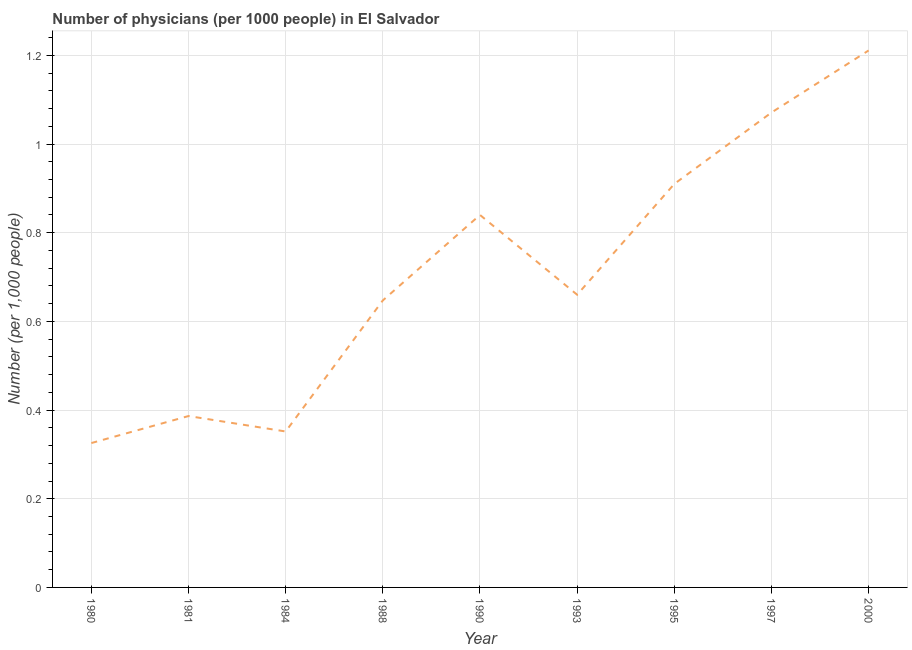What is the number of physicians in 2000?
Give a very brief answer. 1.21. Across all years, what is the maximum number of physicians?
Ensure brevity in your answer.  1.21. Across all years, what is the minimum number of physicians?
Your answer should be very brief. 0.33. In which year was the number of physicians maximum?
Ensure brevity in your answer.  2000. What is the sum of the number of physicians?
Offer a terse response. 6.4. What is the difference between the number of physicians in 1984 and 1997?
Your response must be concise. -0.72. What is the average number of physicians per year?
Offer a terse response. 0.71. What is the median number of physicians?
Your response must be concise. 0.66. What is the ratio of the number of physicians in 1984 to that in 1995?
Ensure brevity in your answer.  0.39. What is the difference between the highest and the second highest number of physicians?
Provide a short and direct response. 0.14. What is the difference between the highest and the lowest number of physicians?
Your answer should be very brief. 0.89. Does the number of physicians monotonically increase over the years?
Provide a succinct answer. No. How many lines are there?
Offer a terse response. 1. How many years are there in the graph?
Ensure brevity in your answer.  9. What is the difference between two consecutive major ticks on the Y-axis?
Your response must be concise. 0.2. Does the graph contain any zero values?
Offer a terse response. No. What is the title of the graph?
Offer a terse response. Number of physicians (per 1000 people) in El Salvador. What is the label or title of the X-axis?
Offer a terse response. Year. What is the label or title of the Y-axis?
Provide a short and direct response. Number (per 1,0 people). What is the Number (per 1,000 people) in 1980?
Your answer should be compact. 0.33. What is the Number (per 1,000 people) of 1981?
Make the answer very short. 0.39. What is the Number (per 1,000 people) in 1984?
Make the answer very short. 0.35. What is the Number (per 1,000 people) in 1988?
Give a very brief answer. 0.65. What is the Number (per 1,000 people) in 1990?
Your answer should be compact. 0.84. What is the Number (per 1,000 people) of 1993?
Your answer should be compact. 0.66. What is the Number (per 1,000 people) in 1995?
Give a very brief answer. 0.91. What is the Number (per 1,000 people) of 1997?
Keep it short and to the point. 1.07. What is the Number (per 1,000 people) of 2000?
Provide a succinct answer. 1.21. What is the difference between the Number (per 1,000 people) in 1980 and 1981?
Make the answer very short. -0.06. What is the difference between the Number (per 1,000 people) in 1980 and 1984?
Your answer should be very brief. -0.03. What is the difference between the Number (per 1,000 people) in 1980 and 1988?
Keep it short and to the point. -0.32. What is the difference between the Number (per 1,000 people) in 1980 and 1990?
Make the answer very short. -0.51. What is the difference between the Number (per 1,000 people) in 1980 and 1993?
Give a very brief answer. -0.33. What is the difference between the Number (per 1,000 people) in 1980 and 1995?
Your answer should be very brief. -0.58. What is the difference between the Number (per 1,000 people) in 1980 and 1997?
Your answer should be compact. -0.75. What is the difference between the Number (per 1,000 people) in 1980 and 2000?
Provide a short and direct response. -0.89. What is the difference between the Number (per 1,000 people) in 1981 and 1984?
Your answer should be very brief. 0.03. What is the difference between the Number (per 1,000 people) in 1981 and 1988?
Your answer should be very brief. -0.26. What is the difference between the Number (per 1,000 people) in 1981 and 1990?
Make the answer very short. -0.45. What is the difference between the Number (per 1,000 people) in 1981 and 1993?
Your answer should be very brief. -0.27. What is the difference between the Number (per 1,000 people) in 1981 and 1995?
Provide a succinct answer. -0.52. What is the difference between the Number (per 1,000 people) in 1981 and 1997?
Ensure brevity in your answer.  -0.68. What is the difference between the Number (per 1,000 people) in 1981 and 2000?
Your answer should be very brief. -0.82. What is the difference between the Number (per 1,000 people) in 1984 and 1988?
Your response must be concise. -0.3. What is the difference between the Number (per 1,000 people) in 1984 and 1990?
Your response must be concise. -0.49. What is the difference between the Number (per 1,000 people) in 1984 and 1993?
Your answer should be compact. -0.31. What is the difference between the Number (per 1,000 people) in 1984 and 1995?
Offer a very short reply. -0.56. What is the difference between the Number (per 1,000 people) in 1984 and 1997?
Make the answer very short. -0.72. What is the difference between the Number (per 1,000 people) in 1984 and 2000?
Provide a short and direct response. -0.86. What is the difference between the Number (per 1,000 people) in 1988 and 1990?
Offer a very short reply. -0.19. What is the difference between the Number (per 1,000 people) in 1988 and 1993?
Your answer should be compact. -0.01. What is the difference between the Number (per 1,000 people) in 1988 and 1995?
Provide a short and direct response. -0.26. What is the difference between the Number (per 1,000 people) in 1988 and 1997?
Ensure brevity in your answer.  -0.42. What is the difference between the Number (per 1,000 people) in 1988 and 2000?
Keep it short and to the point. -0.56. What is the difference between the Number (per 1,000 people) in 1990 and 1993?
Keep it short and to the point. 0.18. What is the difference between the Number (per 1,000 people) in 1990 and 1995?
Your response must be concise. -0.07. What is the difference between the Number (per 1,000 people) in 1990 and 1997?
Your response must be concise. -0.23. What is the difference between the Number (per 1,000 people) in 1990 and 2000?
Give a very brief answer. -0.37. What is the difference between the Number (per 1,000 people) in 1993 and 1995?
Ensure brevity in your answer.  -0.25. What is the difference between the Number (per 1,000 people) in 1993 and 1997?
Offer a terse response. -0.41. What is the difference between the Number (per 1,000 people) in 1993 and 2000?
Give a very brief answer. -0.55. What is the difference between the Number (per 1,000 people) in 1995 and 1997?
Make the answer very short. -0.16. What is the difference between the Number (per 1,000 people) in 1995 and 2000?
Give a very brief answer. -0.3. What is the difference between the Number (per 1,000 people) in 1997 and 2000?
Keep it short and to the point. -0.14. What is the ratio of the Number (per 1,000 people) in 1980 to that in 1981?
Provide a succinct answer. 0.84. What is the ratio of the Number (per 1,000 people) in 1980 to that in 1984?
Provide a short and direct response. 0.93. What is the ratio of the Number (per 1,000 people) in 1980 to that in 1988?
Provide a short and direct response. 0.5. What is the ratio of the Number (per 1,000 people) in 1980 to that in 1990?
Your response must be concise. 0.39. What is the ratio of the Number (per 1,000 people) in 1980 to that in 1993?
Offer a very short reply. 0.49. What is the ratio of the Number (per 1,000 people) in 1980 to that in 1995?
Offer a very short reply. 0.36. What is the ratio of the Number (per 1,000 people) in 1980 to that in 1997?
Your answer should be very brief. 0.3. What is the ratio of the Number (per 1,000 people) in 1980 to that in 2000?
Your response must be concise. 0.27. What is the ratio of the Number (per 1,000 people) in 1981 to that in 1984?
Offer a very short reply. 1.1. What is the ratio of the Number (per 1,000 people) in 1981 to that in 1988?
Ensure brevity in your answer.  0.6. What is the ratio of the Number (per 1,000 people) in 1981 to that in 1990?
Your response must be concise. 0.46. What is the ratio of the Number (per 1,000 people) in 1981 to that in 1993?
Ensure brevity in your answer.  0.59. What is the ratio of the Number (per 1,000 people) in 1981 to that in 1995?
Keep it short and to the point. 0.42. What is the ratio of the Number (per 1,000 people) in 1981 to that in 1997?
Keep it short and to the point. 0.36. What is the ratio of the Number (per 1,000 people) in 1981 to that in 2000?
Ensure brevity in your answer.  0.32. What is the ratio of the Number (per 1,000 people) in 1984 to that in 1988?
Give a very brief answer. 0.54. What is the ratio of the Number (per 1,000 people) in 1984 to that in 1990?
Keep it short and to the point. 0.42. What is the ratio of the Number (per 1,000 people) in 1984 to that in 1993?
Provide a succinct answer. 0.53. What is the ratio of the Number (per 1,000 people) in 1984 to that in 1995?
Offer a terse response. 0.39. What is the ratio of the Number (per 1,000 people) in 1984 to that in 1997?
Your response must be concise. 0.33. What is the ratio of the Number (per 1,000 people) in 1984 to that in 2000?
Your answer should be compact. 0.29. What is the ratio of the Number (per 1,000 people) in 1988 to that in 1990?
Keep it short and to the point. 0.77. What is the ratio of the Number (per 1,000 people) in 1988 to that in 1993?
Give a very brief answer. 0.98. What is the ratio of the Number (per 1,000 people) in 1988 to that in 1995?
Your answer should be compact. 0.71. What is the ratio of the Number (per 1,000 people) in 1988 to that in 1997?
Keep it short and to the point. 0.6. What is the ratio of the Number (per 1,000 people) in 1988 to that in 2000?
Your answer should be compact. 0.54. What is the ratio of the Number (per 1,000 people) in 1990 to that in 1993?
Your response must be concise. 1.27. What is the ratio of the Number (per 1,000 people) in 1990 to that in 1995?
Give a very brief answer. 0.92. What is the ratio of the Number (per 1,000 people) in 1990 to that in 1997?
Ensure brevity in your answer.  0.78. What is the ratio of the Number (per 1,000 people) in 1990 to that in 2000?
Your answer should be very brief. 0.69. What is the ratio of the Number (per 1,000 people) in 1993 to that in 1995?
Keep it short and to the point. 0.72. What is the ratio of the Number (per 1,000 people) in 1993 to that in 1997?
Offer a very short reply. 0.62. What is the ratio of the Number (per 1,000 people) in 1993 to that in 2000?
Your answer should be very brief. 0.55. What is the ratio of the Number (per 1,000 people) in 1995 to that in 1997?
Offer a very short reply. 0.85. What is the ratio of the Number (per 1,000 people) in 1995 to that in 2000?
Your answer should be compact. 0.75. What is the ratio of the Number (per 1,000 people) in 1997 to that in 2000?
Provide a succinct answer. 0.88. 